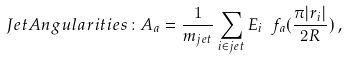<formula> <loc_0><loc_0><loc_500><loc_500>J e t A n g u l a r i t i e s \colon A _ { a } = \frac { 1 } { m _ { j e t } } \sum _ { i \in j e t } E _ { i } \ f _ { a } ( \frac { \pi | r _ { i } | } { 2 R } ) \, ,</formula> 